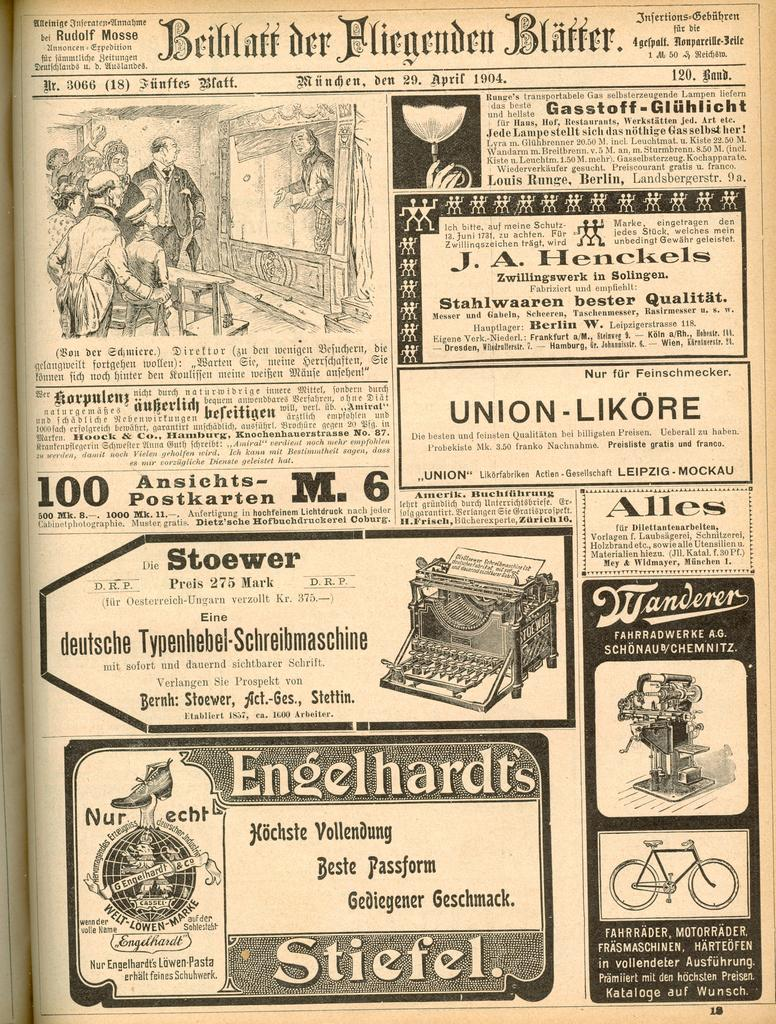<image>
Relay a brief, clear account of the picture shown. A German paper displays many such as for Engelhardt's boots or Stoewer typewriters. 